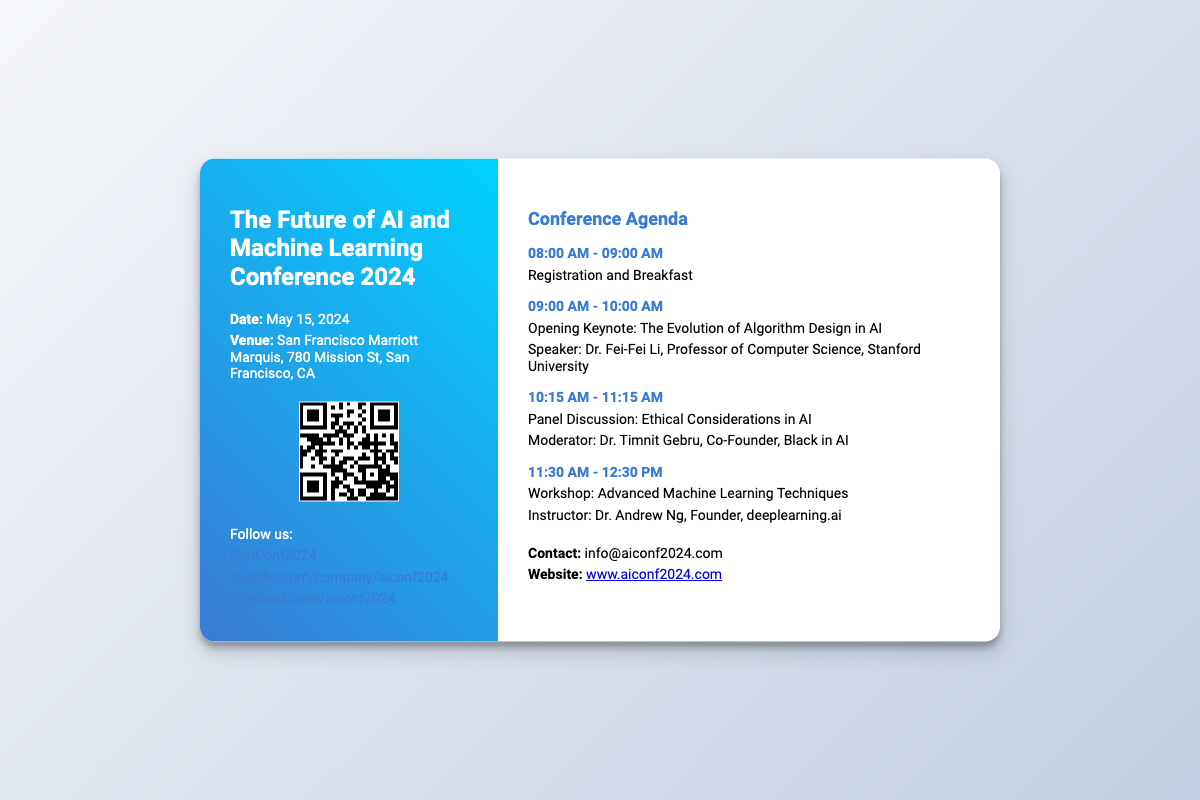What is the date of the conference? The date of the conference is explicitly stated in the document.
Answer: May 15, 2024 Who is the speaker for the opening keynote? The opening keynote speaker is mentioned directly in the agenda section of the document.
Answer: Dr. Fei-Fei Li What is the venue of the conference? The venue for the event is outlined in the ticket details.
Answer: San Francisco Marriott Marquis What time does registration start? The start time for registration is specified in the agenda.
Answer: 08:00 AM Which session covers Ethical Considerations in AI? The document lists the panel discussion along with its details to identify the session.
Answer: Panel Discussion How many hours is the networking lunch scheduled for? The duration of the networking lunch is included in the agenda.
Answer: 1 hour What is the title of the closing keynote? The title is provided in the agenda details.
Answer: Future Trends in AI and Machine Learning Who is hosting the Advanced Machine Learning Techniques workshop? The instructor for the workshop is mentioned in the agenda.
Answer: Dr. Andrew Ng What is the website for the conference? The website is presented at the end of the document.
Answer: www.aiconf2024.com 